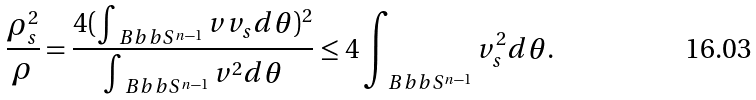<formula> <loc_0><loc_0><loc_500><loc_500>\frac { \rho _ { s } ^ { 2 } } \rho = \frac { 4 ( \int _ { \ B b b S ^ { n - 1 } } v v _ { s } d \theta ) ^ { 2 } } { \int _ { \ B b b S ^ { n - 1 } } v ^ { 2 } d \theta } \leq 4 \int _ { \ B b b S ^ { n - 1 } } v _ { s } ^ { 2 } d \theta .</formula> 